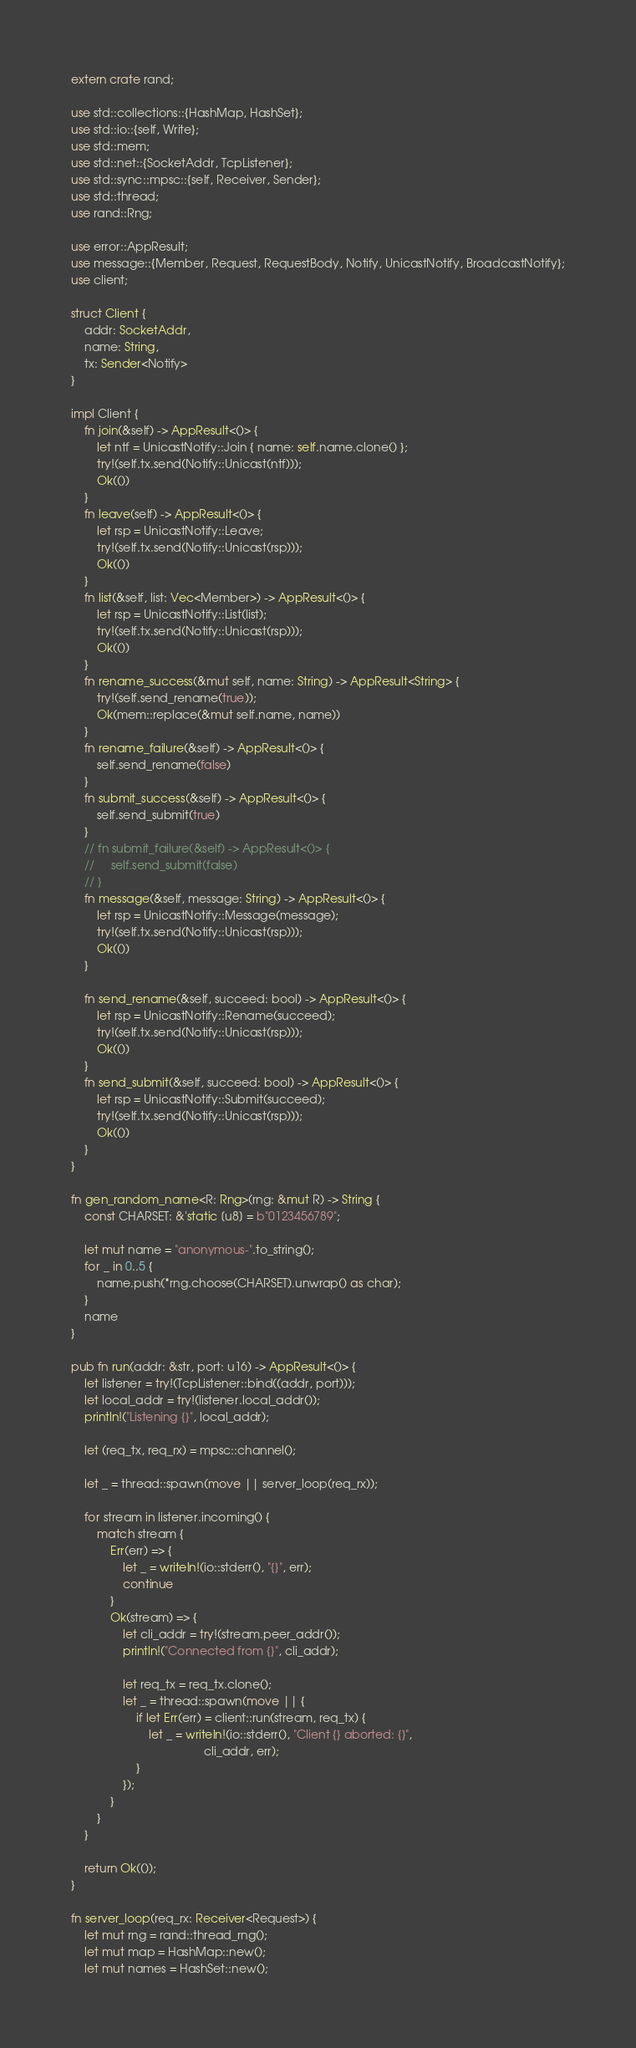Convert code to text. <code><loc_0><loc_0><loc_500><loc_500><_Rust_>extern crate rand;

use std::collections::{HashMap, HashSet};
use std::io::{self, Write};
use std::mem;
use std::net::{SocketAddr, TcpListener};
use std::sync::mpsc::{self, Receiver, Sender};
use std::thread;
use rand::Rng;

use error::AppResult;
use message::{Member, Request, RequestBody, Notify, UnicastNotify, BroadcastNotify};
use client;

struct Client {
    addr: SocketAddr,
    name: String,
    tx: Sender<Notify>
}

impl Client {
    fn join(&self) -> AppResult<()> {
        let ntf = UnicastNotify::Join { name: self.name.clone() };
        try!(self.tx.send(Notify::Unicast(ntf)));
        Ok(())
    }
    fn leave(self) -> AppResult<()> {
        let rsp = UnicastNotify::Leave;
        try!(self.tx.send(Notify::Unicast(rsp)));
        Ok(())
    }
    fn list(&self, list: Vec<Member>) -> AppResult<()> {
        let rsp = UnicastNotify::List(list);
        try!(self.tx.send(Notify::Unicast(rsp)));
        Ok(())
    }
    fn rename_success(&mut self, name: String) -> AppResult<String> {
        try!(self.send_rename(true));
        Ok(mem::replace(&mut self.name, name))
    }
    fn rename_failure(&self) -> AppResult<()> {
        self.send_rename(false)
    }
    fn submit_success(&self) -> AppResult<()> {
        self.send_submit(true)
    }
    // fn submit_failure(&self) -> AppResult<()> {
    //     self.send_submit(false)
    // }
    fn message(&self, message: String) -> AppResult<()> {
        let rsp = UnicastNotify::Message(message);
        try!(self.tx.send(Notify::Unicast(rsp)));
        Ok(())
    }

    fn send_rename(&self, succeed: bool) -> AppResult<()> {
        let rsp = UnicastNotify::Rename(succeed);
        try!(self.tx.send(Notify::Unicast(rsp)));
        Ok(())
    }
    fn send_submit(&self, succeed: bool) -> AppResult<()> {
        let rsp = UnicastNotify::Submit(succeed);
        try!(self.tx.send(Notify::Unicast(rsp)));
        Ok(())
    }
}

fn gen_random_name<R: Rng>(rng: &mut R) -> String {
    const CHARSET: &'static [u8] = b"0123456789";

    let mut name = "anonymous-".to_string();
    for _ in 0..5 {
        name.push(*rng.choose(CHARSET).unwrap() as char);
    }
    name
}

pub fn run(addr: &str, port: u16) -> AppResult<()> {
    let listener = try!(TcpListener::bind((addr, port)));
    let local_addr = try!(listener.local_addr());
    println!("Listening {}", local_addr);

    let (req_tx, req_rx) = mpsc::channel();

    let _ = thread::spawn(move || server_loop(req_rx));

    for stream in listener.incoming() {
        match stream {
            Err(err) => {
                let _ = writeln!(io::stderr(), "{}", err);
                continue
            }
            Ok(stream) => {
                let cli_addr = try!(stream.peer_addr());
                println!("Connected from {}", cli_addr);

                let req_tx = req_tx.clone();
                let _ = thread::spawn(move || {
                    if let Err(err) = client::run(stream, req_tx) {
                        let _ = writeln!(io::stderr(), "Client {} aborted: {}",
                                         cli_addr, err);
                    }
                });
            }
        }
    }

    return Ok(());
}

fn server_loop(req_rx: Receiver<Request>) {
    let mut rng = rand::thread_rng();
    let mut map = HashMap::new();
    let mut names = HashSet::new();
</code> 